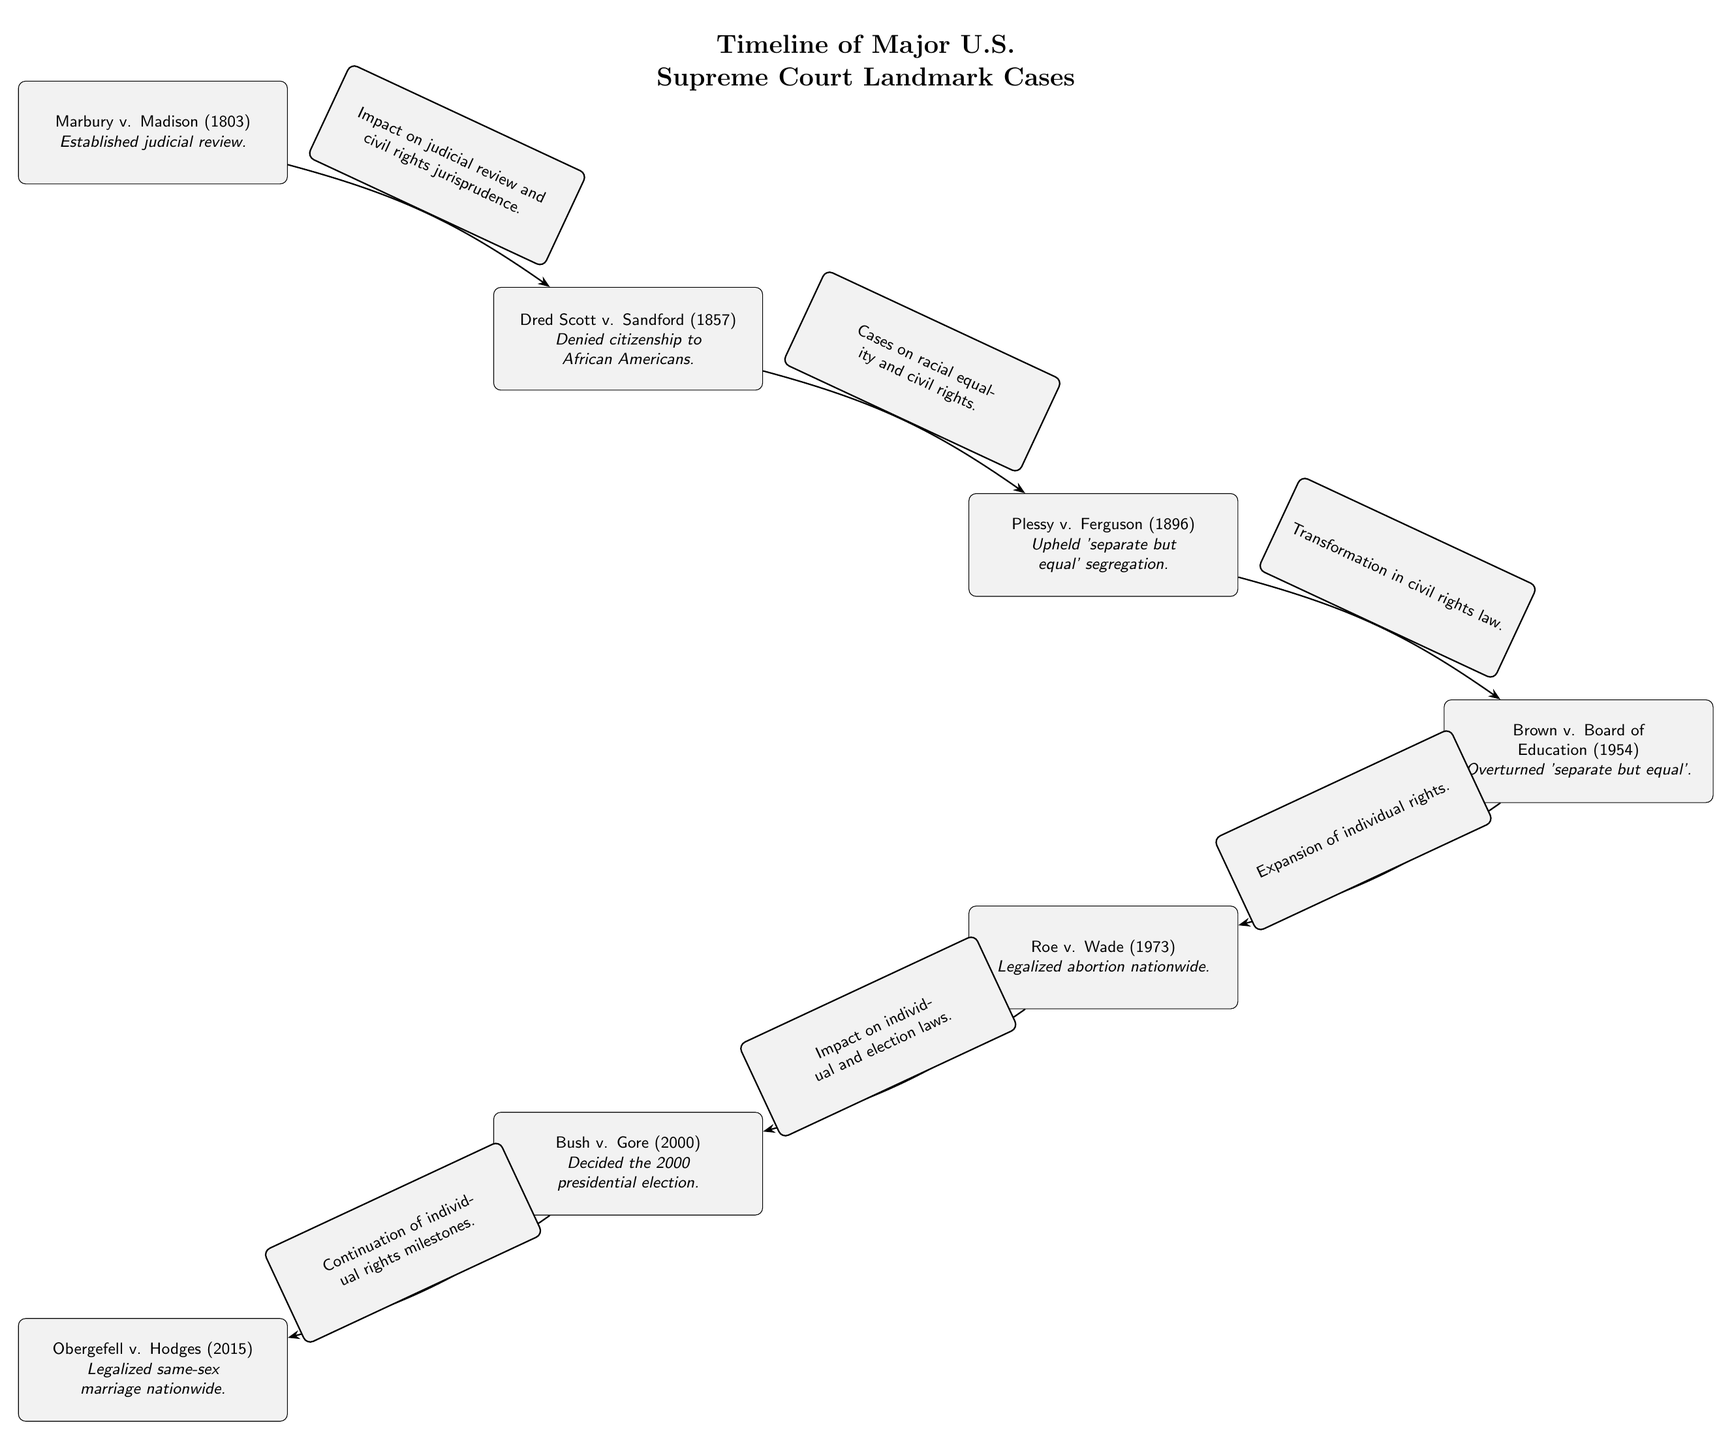What is the first case listed in the timeline? The first case displayed in the timeline is Marbury v. Madison, which is located at the top of the diagram.
Answer: Marbury v. Madison How many landmark cases are depicted in the diagram? The diagram contains a total of six landmark cases represented as nodes.
Answer: 6 What judgment did Brown v. Board of Education make? The diagram states that Brown v. Board of Education overturned 'separate but equal', which directly addresses the legal standing on racial segregation.
Answer: Overturned 'separate but equal' Which case is associated with the impact on individual rights milestones? According to the diagram, Bush v. Gore is the case specifically linked to the continuation of individual rights milestones, as indicated in the edge label leading to Obergefell v. Hodges.
Answer: Bush v. Gore What key decision was made in Roe v. Wade? The edge on the diagram specifies that Roe v. Wade legalized abortion nationwide, which is a significant landmark decision regarding individual rights.
Answer: Legalized abortion nationwide What does the edge label from Brown to Roe indicate? The edge label from Brown to Roe illustrates that Brown v. Board of Education expanded individual rights, which lays the groundwork for subsequent cases like Roe v. Wade.
Answer: Expansion of individual rights Which case followed Dred Scott v. Sandford in the timeline? In the timeline, the case that follows Dred Scott v. Sandford is Plessy v. Ferguson, as shown by their vertical arrangement in the diagram.
Answer: Plessy v. Ferguson What major principle was established in Marbury v. Madison? The diagram notes that Marbury v. Madison established the principle of judicial review, a foundational element of the U.S. legal system.
Answer: Established judicial review What is the significance of Obergefell v. Hodges in this timeline? Obergefell v. Hodges is significant in the timeline as it legalized same-sex marriage nationwide, representing a pivotal moment in the evolution of civil rights.
Answer: Legalized same-sex marriage nationwide 